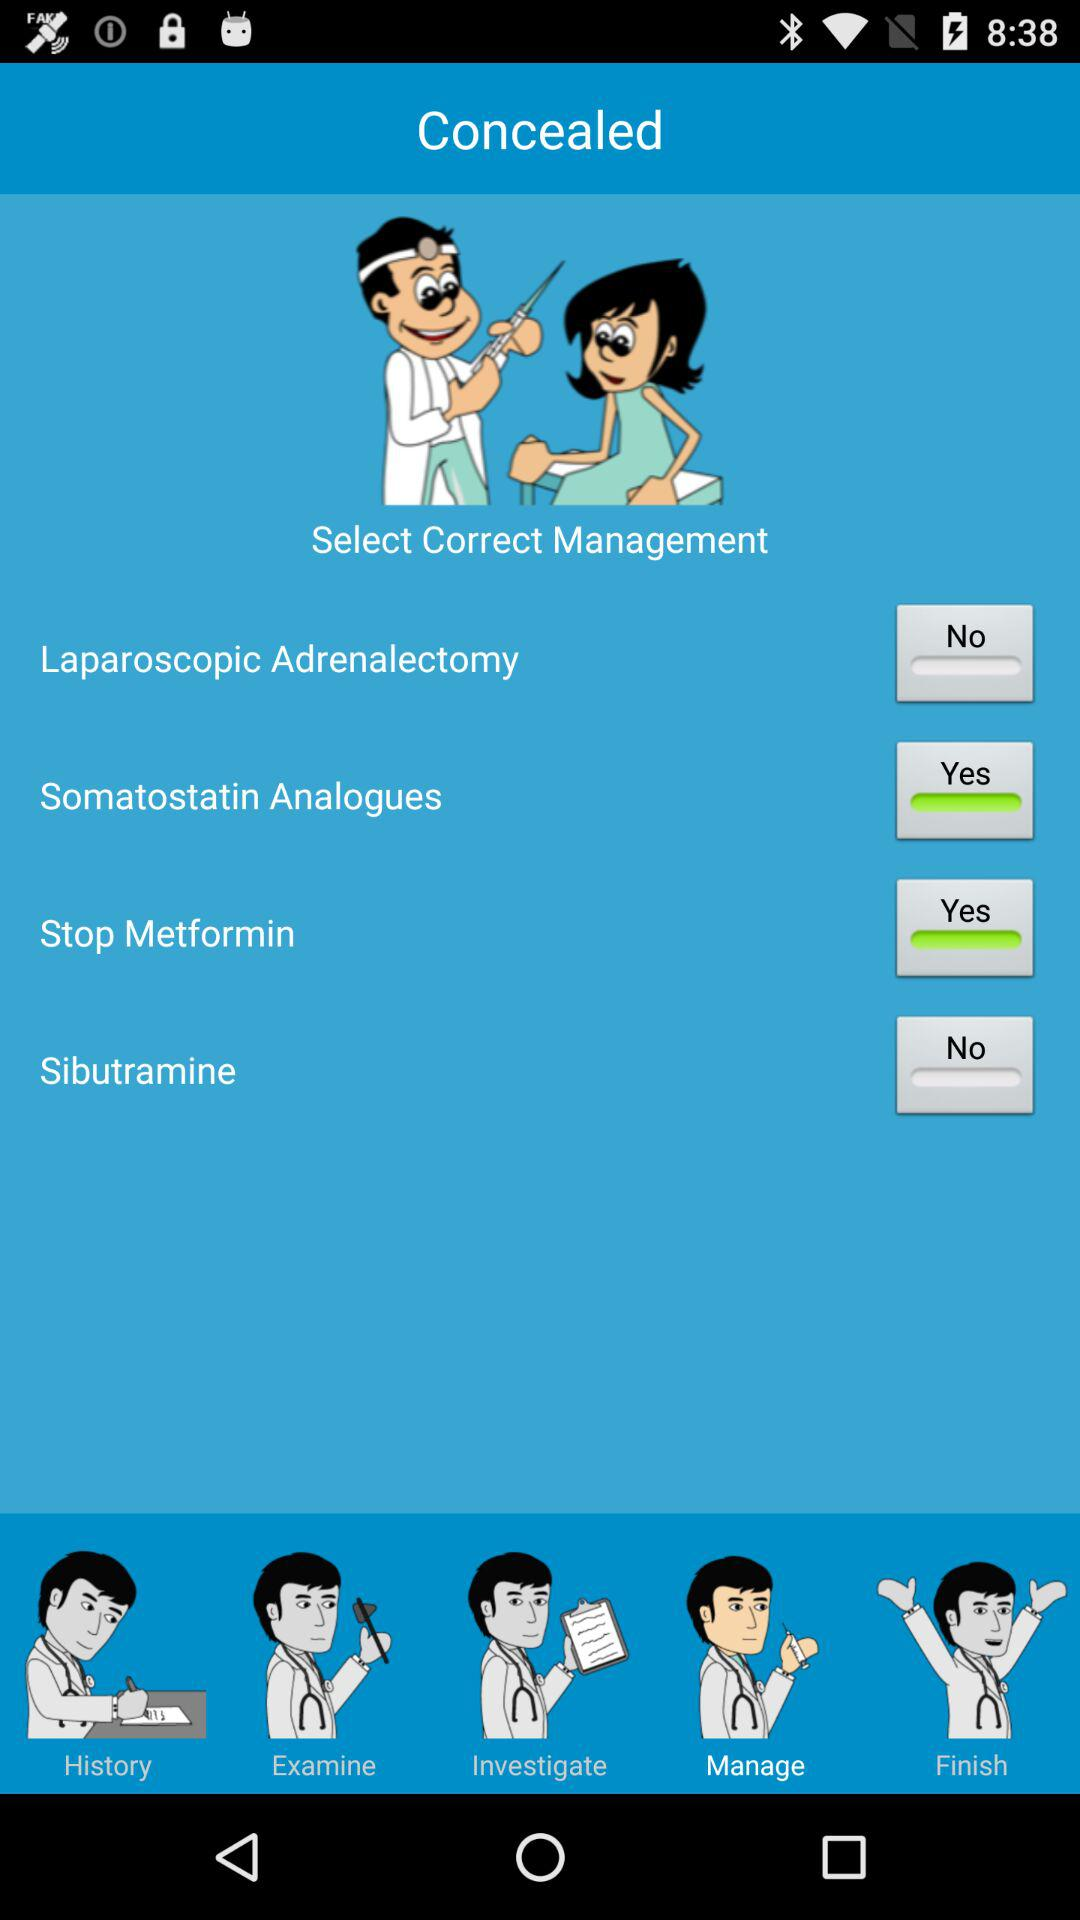What is the status of "Stop Metformin"? The status is "Yes". 